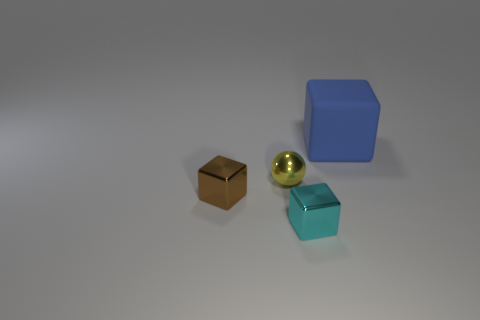Are there any other things that have the same size as the blue matte thing?
Your answer should be compact. No. Is the number of matte blocks less than the number of small green blocks?
Make the answer very short. No. There is a object that is to the left of the tiny yellow object; does it have the same size as the metallic block on the right side of the brown object?
Keep it short and to the point. Yes. How many cyan objects are either tiny metallic objects or big things?
Ensure brevity in your answer.  1. Are there more big green shiny blocks than small metal things?
Provide a short and direct response. No. Is the tiny sphere the same color as the large thing?
Your answer should be very brief. No. How many things are big rubber blocks or blocks that are behind the small yellow shiny object?
Make the answer very short. 1. How many other objects are the same shape as the tiny yellow shiny object?
Your response must be concise. 0. Is the number of big rubber things to the left of the cyan metal thing less than the number of blue matte things that are to the right of the brown shiny block?
Your response must be concise. Yes. Is there anything else that is made of the same material as the large blue cube?
Offer a terse response. No. 